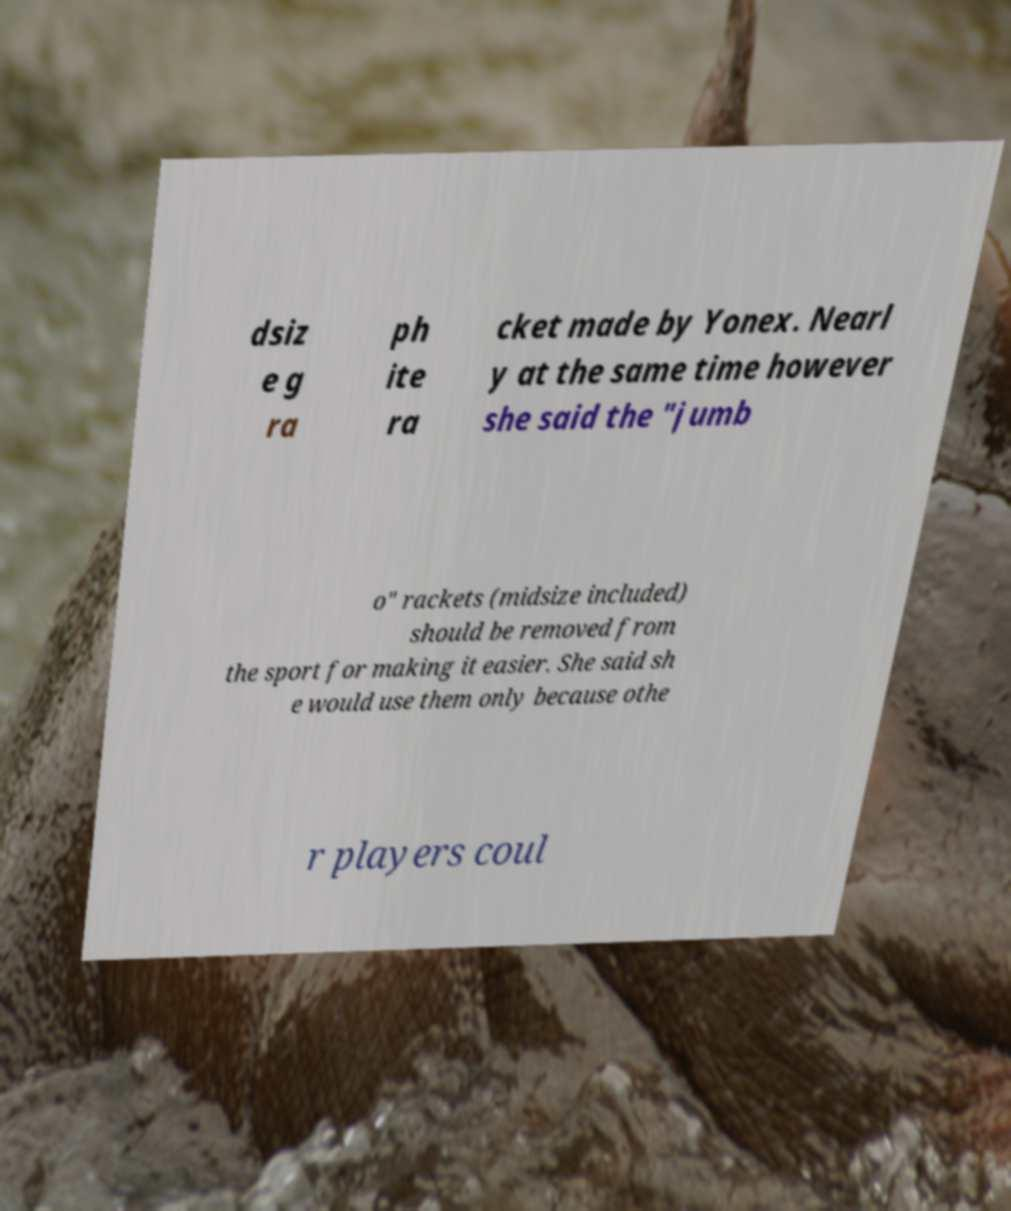Could you extract and type out the text from this image? dsiz e g ra ph ite ra cket made by Yonex. Nearl y at the same time however she said the "jumb o" rackets (midsize included) should be removed from the sport for making it easier. She said sh e would use them only because othe r players coul 